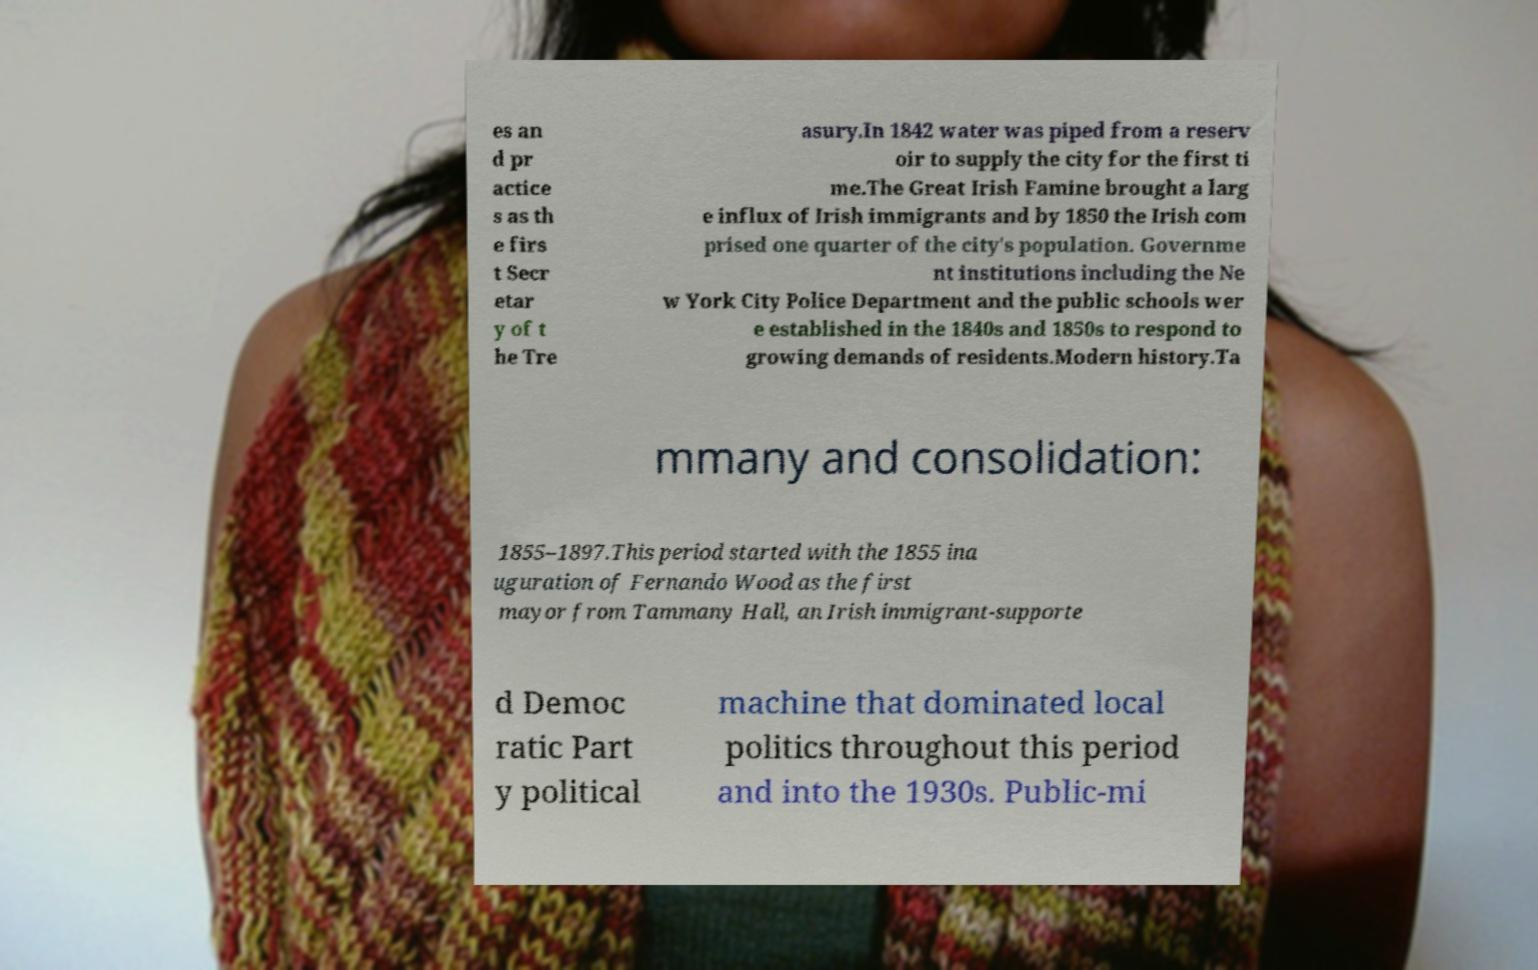Can you accurately transcribe the text from the provided image for me? es an d pr actice s as th e firs t Secr etar y of t he Tre asury.In 1842 water was piped from a reserv oir to supply the city for the first ti me.The Great Irish Famine brought a larg e influx of Irish immigrants and by 1850 the Irish com prised one quarter of the city's population. Governme nt institutions including the Ne w York City Police Department and the public schools wer e established in the 1840s and 1850s to respond to growing demands of residents.Modern history.Ta mmany and consolidation: 1855–1897.This period started with the 1855 ina uguration of Fernando Wood as the first mayor from Tammany Hall, an Irish immigrant-supporte d Democ ratic Part y political machine that dominated local politics throughout this period and into the 1930s. Public-mi 